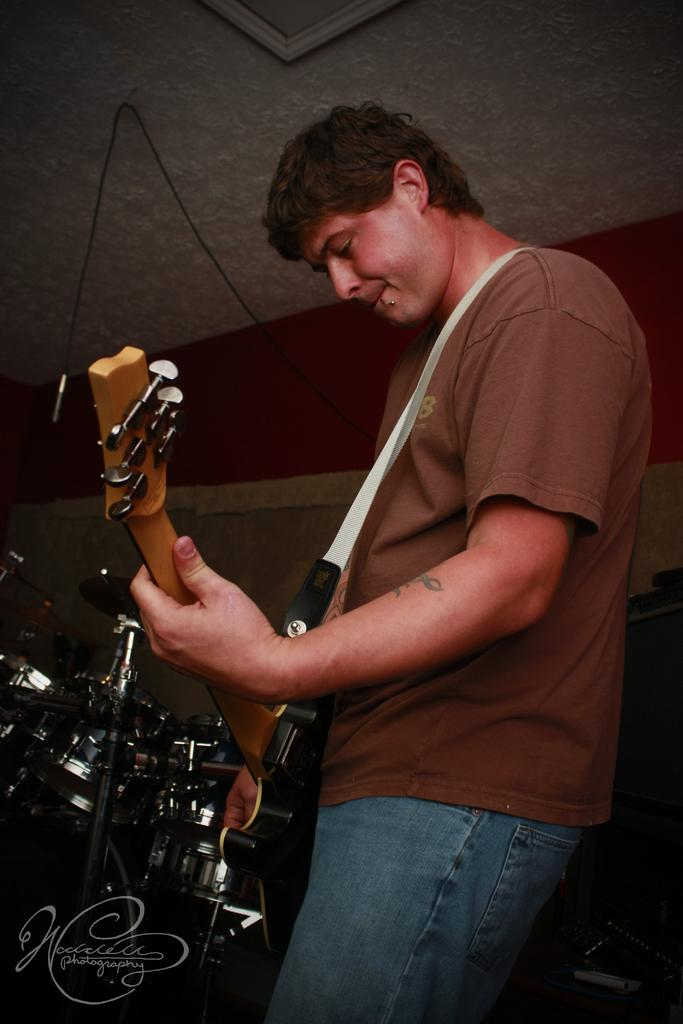Who is present in the image? There is a man in the image. What is the man holding in the image? The man is holding a guitar. What else can be seen in the background of the image? There are musical instruments in the background of the image. What type of trousers is the man wearing in the image? The provided facts do not mention the man's trousers, so we cannot determine the type of trousers he is wearing. What fictional character does the man in the image represent? The provided facts do not mention any fictional characters, so we cannot determine if the man represents any fictional character. 